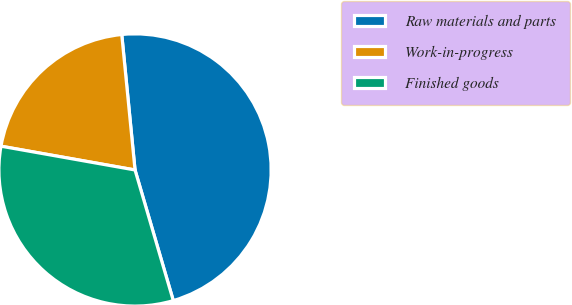<chart> <loc_0><loc_0><loc_500><loc_500><pie_chart><fcel>Raw materials and parts<fcel>Work-in-progress<fcel>Finished goods<nl><fcel>47.02%<fcel>20.65%<fcel>32.33%<nl></chart> 